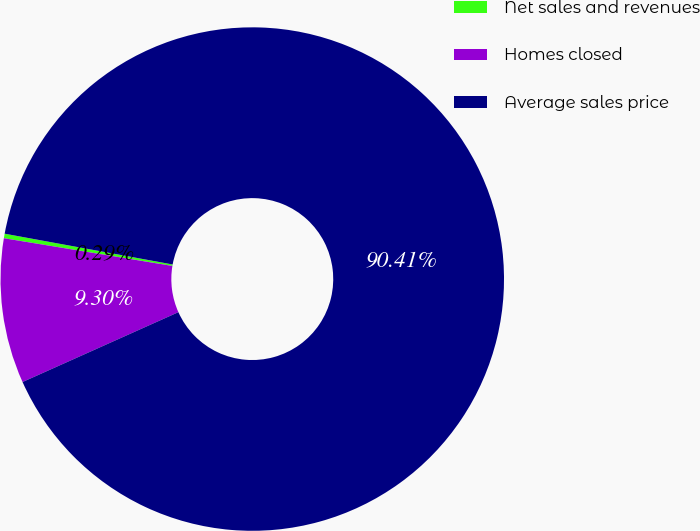Convert chart to OTSL. <chart><loc_0><loc_0><loc_500><loc_500><pie_chart><fcel>Net sales and revenues<fcel>Homes closed<fcel>Average sales price<nl><fcel>0.29%<fcel>9.3%<fcel>90.41%<nl></chart> 